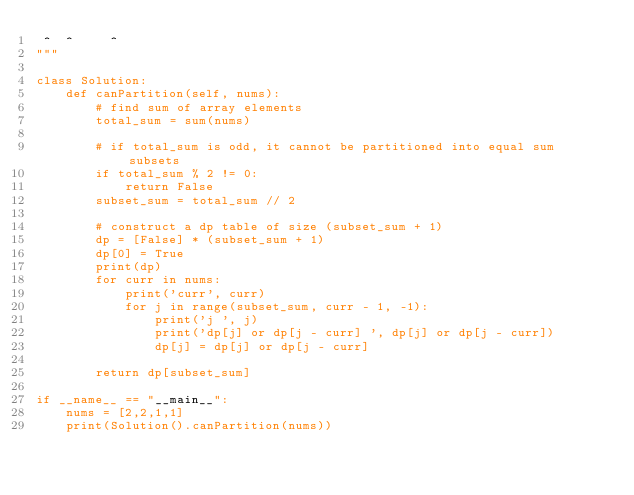<code> <loc_0><loc_0><loc_500><loc_500><_Python_> ^  ^     ^
"""

class Solution:
    def canPartition(self, nums):
        # find sum of array elements
        total_sum = sum(nums)

        # if total_sum is odd, it cannot be partitioned into equal sum subsets
        if total_sum % 2 != 0:
            return False
        subset_sum = total_sum // 2

        # construct a dp table of size (subset_sum + 1)
        dp = [False] * (subset_sum + 1)
        dp[0] = True
        print(dp)
        for curr in nums:
            print('curr', curr)
            for j in range(subset_sum, curr - 1, -1):
                print('j ', j)
                print('dp[j] or dp[j - curr] ', dp[j] or dp[j - curr])
                dp[j] = dp[j] or dp[j - curr]

        return dp[subset_sum]        
        
if __name__ == "__main__":
    nums = [2,2,1,1]
    print(Solution().canPartition(nums))
        </code> 